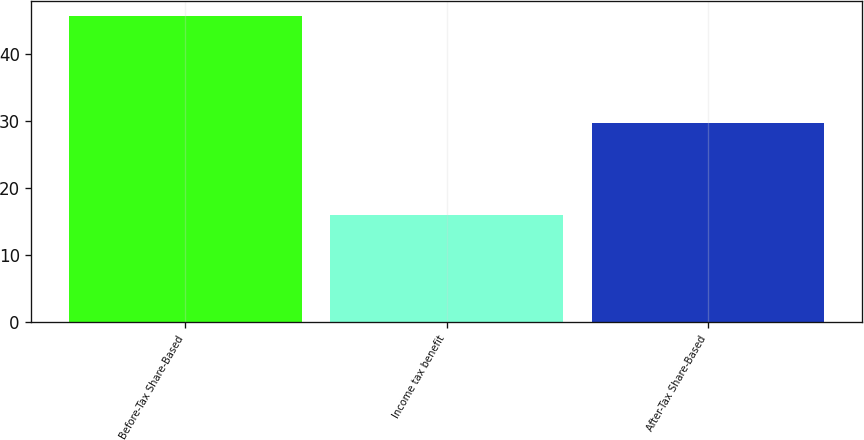<chart> <loc_0><loc_0><loc_500><loc_500><bar_chart><fcel>Before-Tax Share-Based<fcel>Income tax benefit<fcel>After-Tax Share-Based<nl><fcel>45.7<fcel>16<fcel>29.7<nl></chart> 